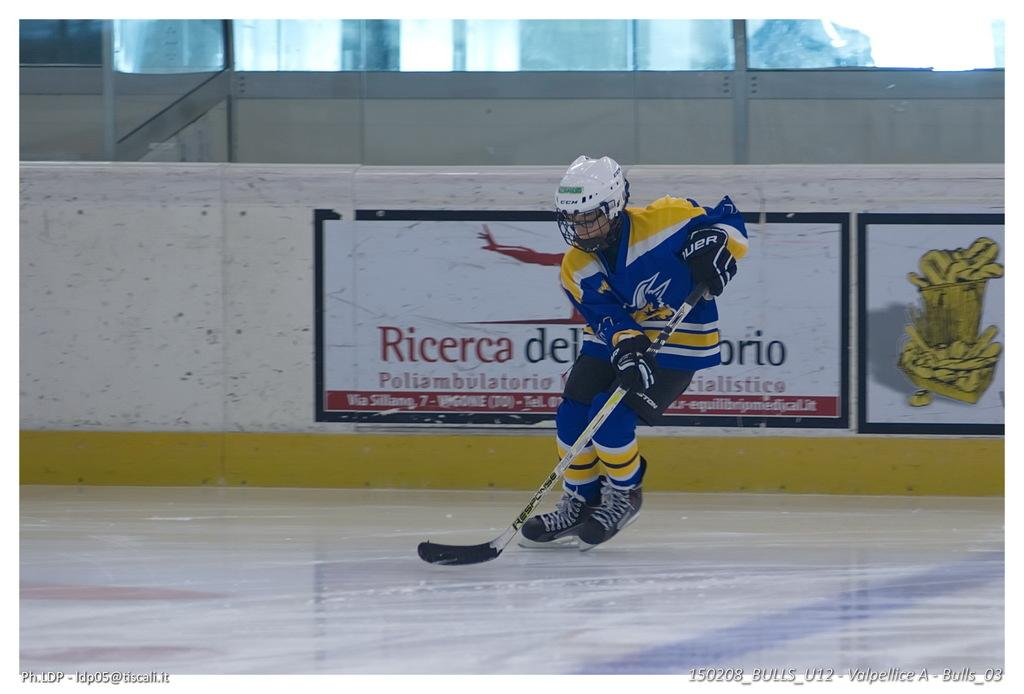What is the main subject of the image? There is a person in the image. What is the person holding in the image? The person is holding a stick. What activity is the person engaged in? The person is playing a game. Can you tell me how many owls are sitting on the person's shoulder in the image? There are no owls present in the image. What type of secretary is assisting the person in the image? There is no secretary present in the image. 